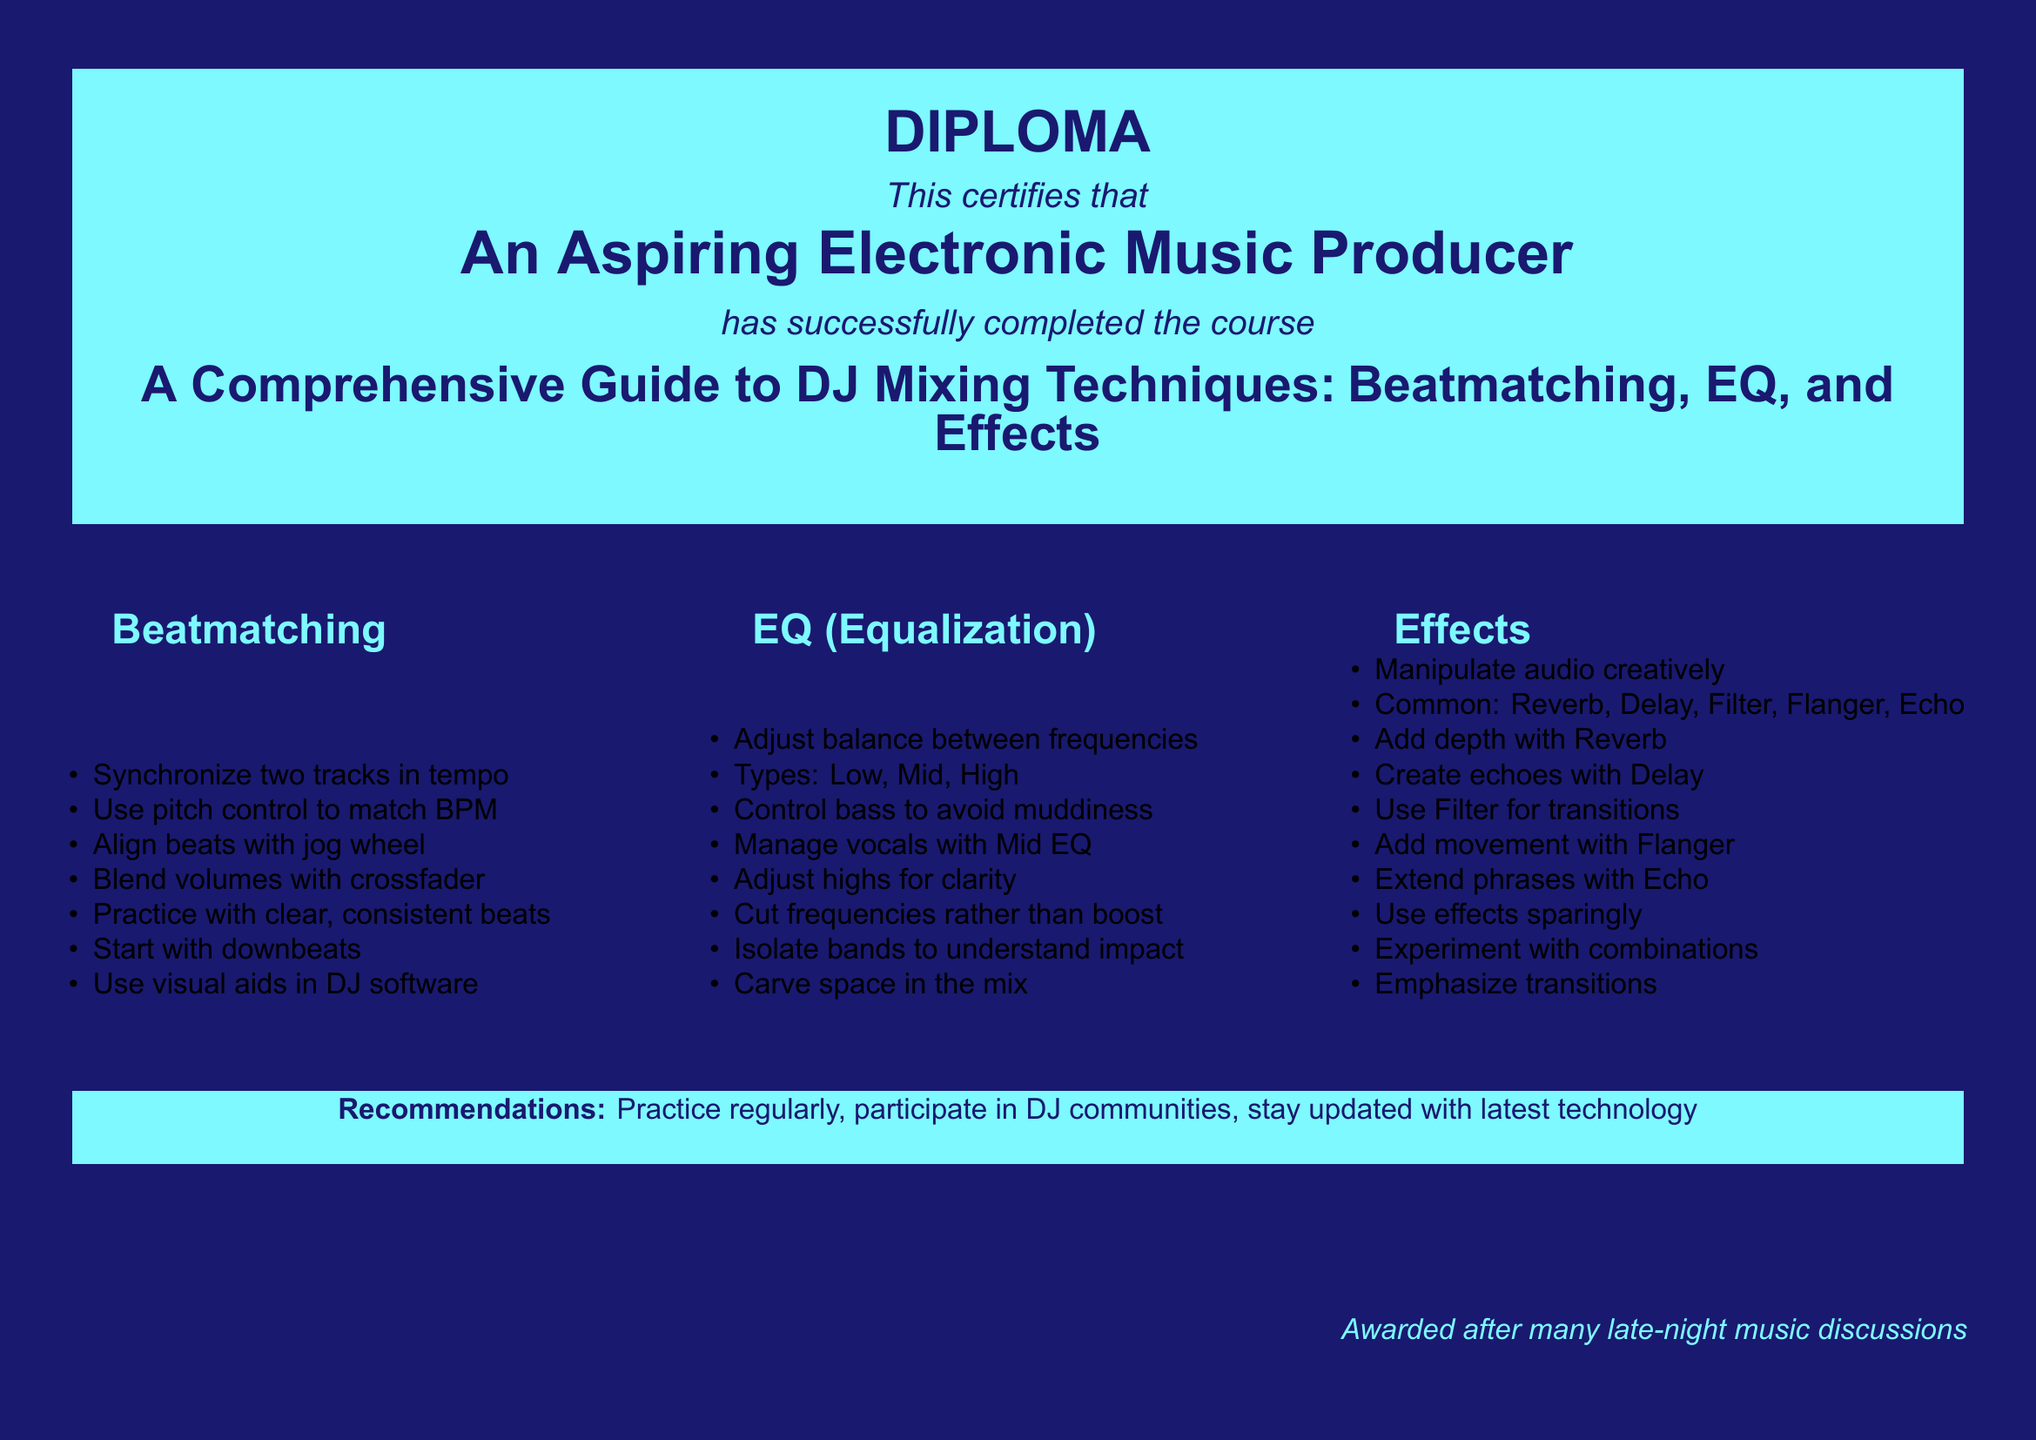what is the title of the diploma? The title of the diploma is clearly specified in the document: "A Comprehensive Guide to DJ Mixing Techniques: Beatmatching, EQ, and Effects."
Answer: A Comprehensive Guide to DJ Mixing Techniques: Beatmatching, EQ, and Effects who is the recipient of the diploma? The document states that the diploma is awarded to "An Aspiring Electronic Music Producer."
Answer: An Aspiring Electronic Music Producer how many sections are listed in the document? The document contains three sections: Beatmatching, EQ (Equalization), and Effects.
Answer: three what is the main focus of the "EQ (Equalization)" section? The EQ section discusses adjusting the balance between frequencies including low, mid, and high.
Answer: adjusting the balance between frequencies what should you do to avoid muddiness in the mix? The document suggests controlling bass to avoid muddiness.
Answer: control bass what is one recommended practice for DJs mentioned in the diploma? The diploma recommends practicing regularly, which is crucial for improving skills.
Answer: Practice regularly name one common effect used in DJ mixing. The document lists several common effects, including Reverb, Delay, and Filter.
Answer: Reverb what is the awarded context mentioned in the diploma? The diploma mentions that it is awarded after many late-night music discussions, which implies a spirited learning environment.
Answer: after many late-night music discussions how does the document suggest to experiment with effects? The document advises to use effects sparingly and experiment with combinations to create unique sounds.
Answer: experiment with combinations 